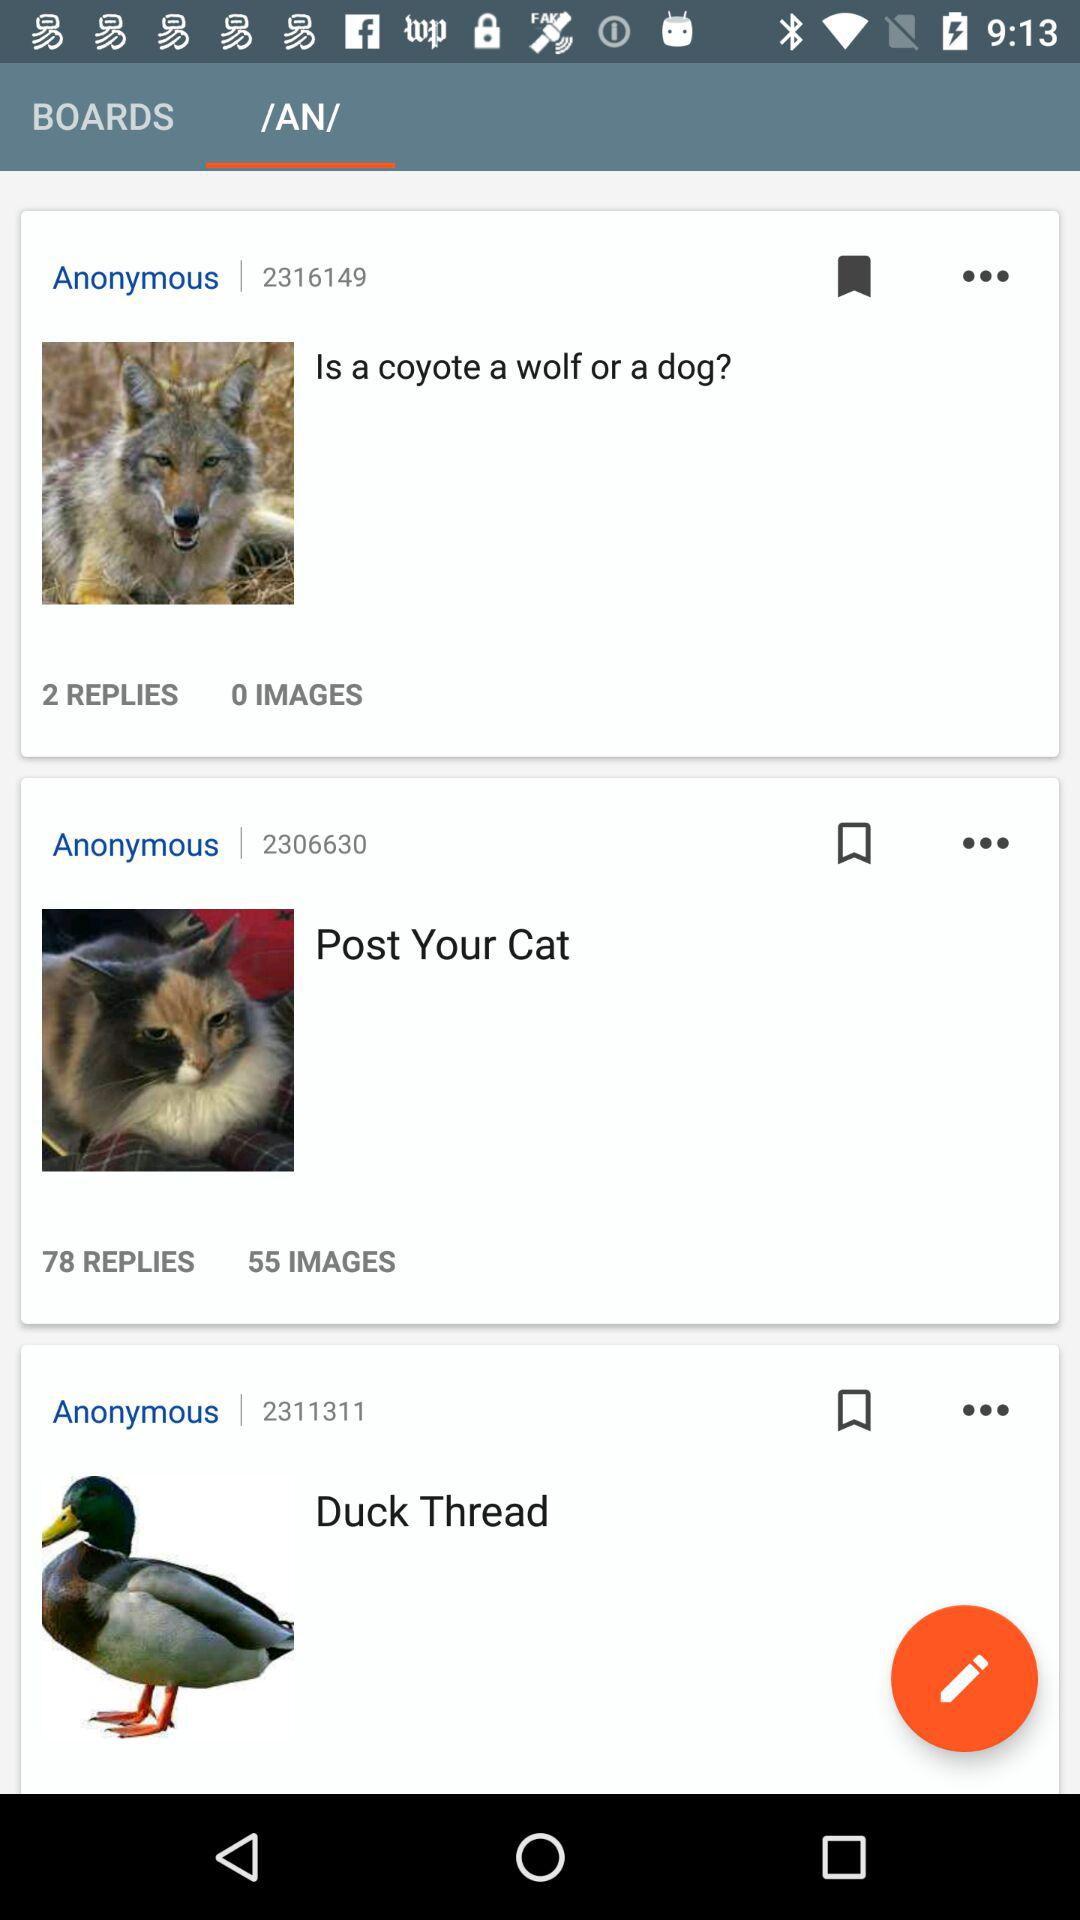Which tab is selected? The selected tab is "/AN/". 